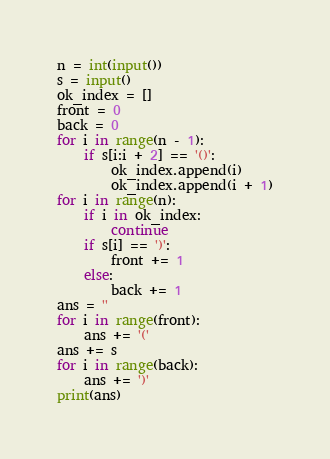<code> <loc_0><loc_0><loc_500><loc_500><_Python_>n = int(input())
s = input()
ok_index = []
front = 0
back = 0
for i in range(n - 1):
    if s[i:i + 2] == '()':
        ok_index.append(i)
        ok_index.append(i + 1)
for i in range(n):
    if i in ok_index:
        continue
    if s[i] == ')':
        front += 1
    else:
        back += 1
ans = ''
for i in range(front):
    ans += '('
ans += s
for i in range(back):
    ans += ')'
print(ans)</code> 